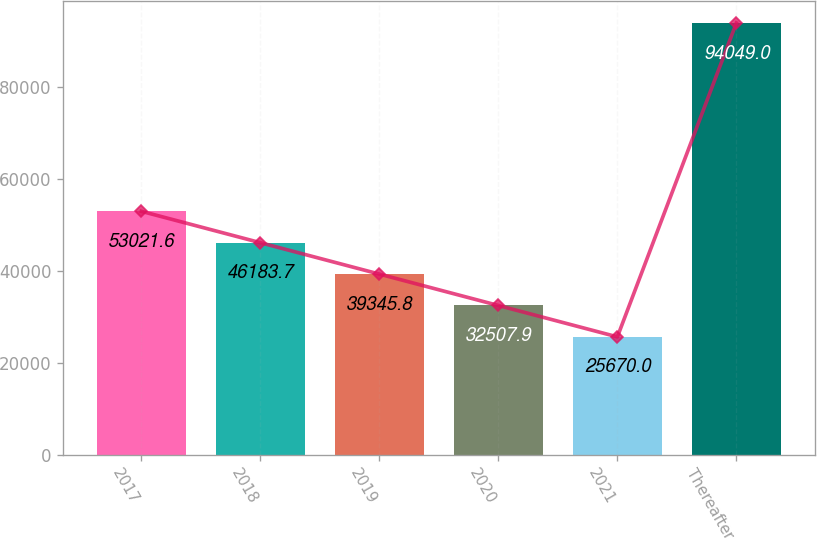Convert chart. <chart><loc_0><loc_0><loc_500><loc_500><bar_chart><fcel>2017<fcel>2018<fcel>2019<fcel>2020<fcel>2021<fcel>Thereafter<nl><fcel>53021.6<fcel>46183.7<fcel>39345.8<fcel>32507.9<fcel>25670<fcel>94049<nl></chart> 